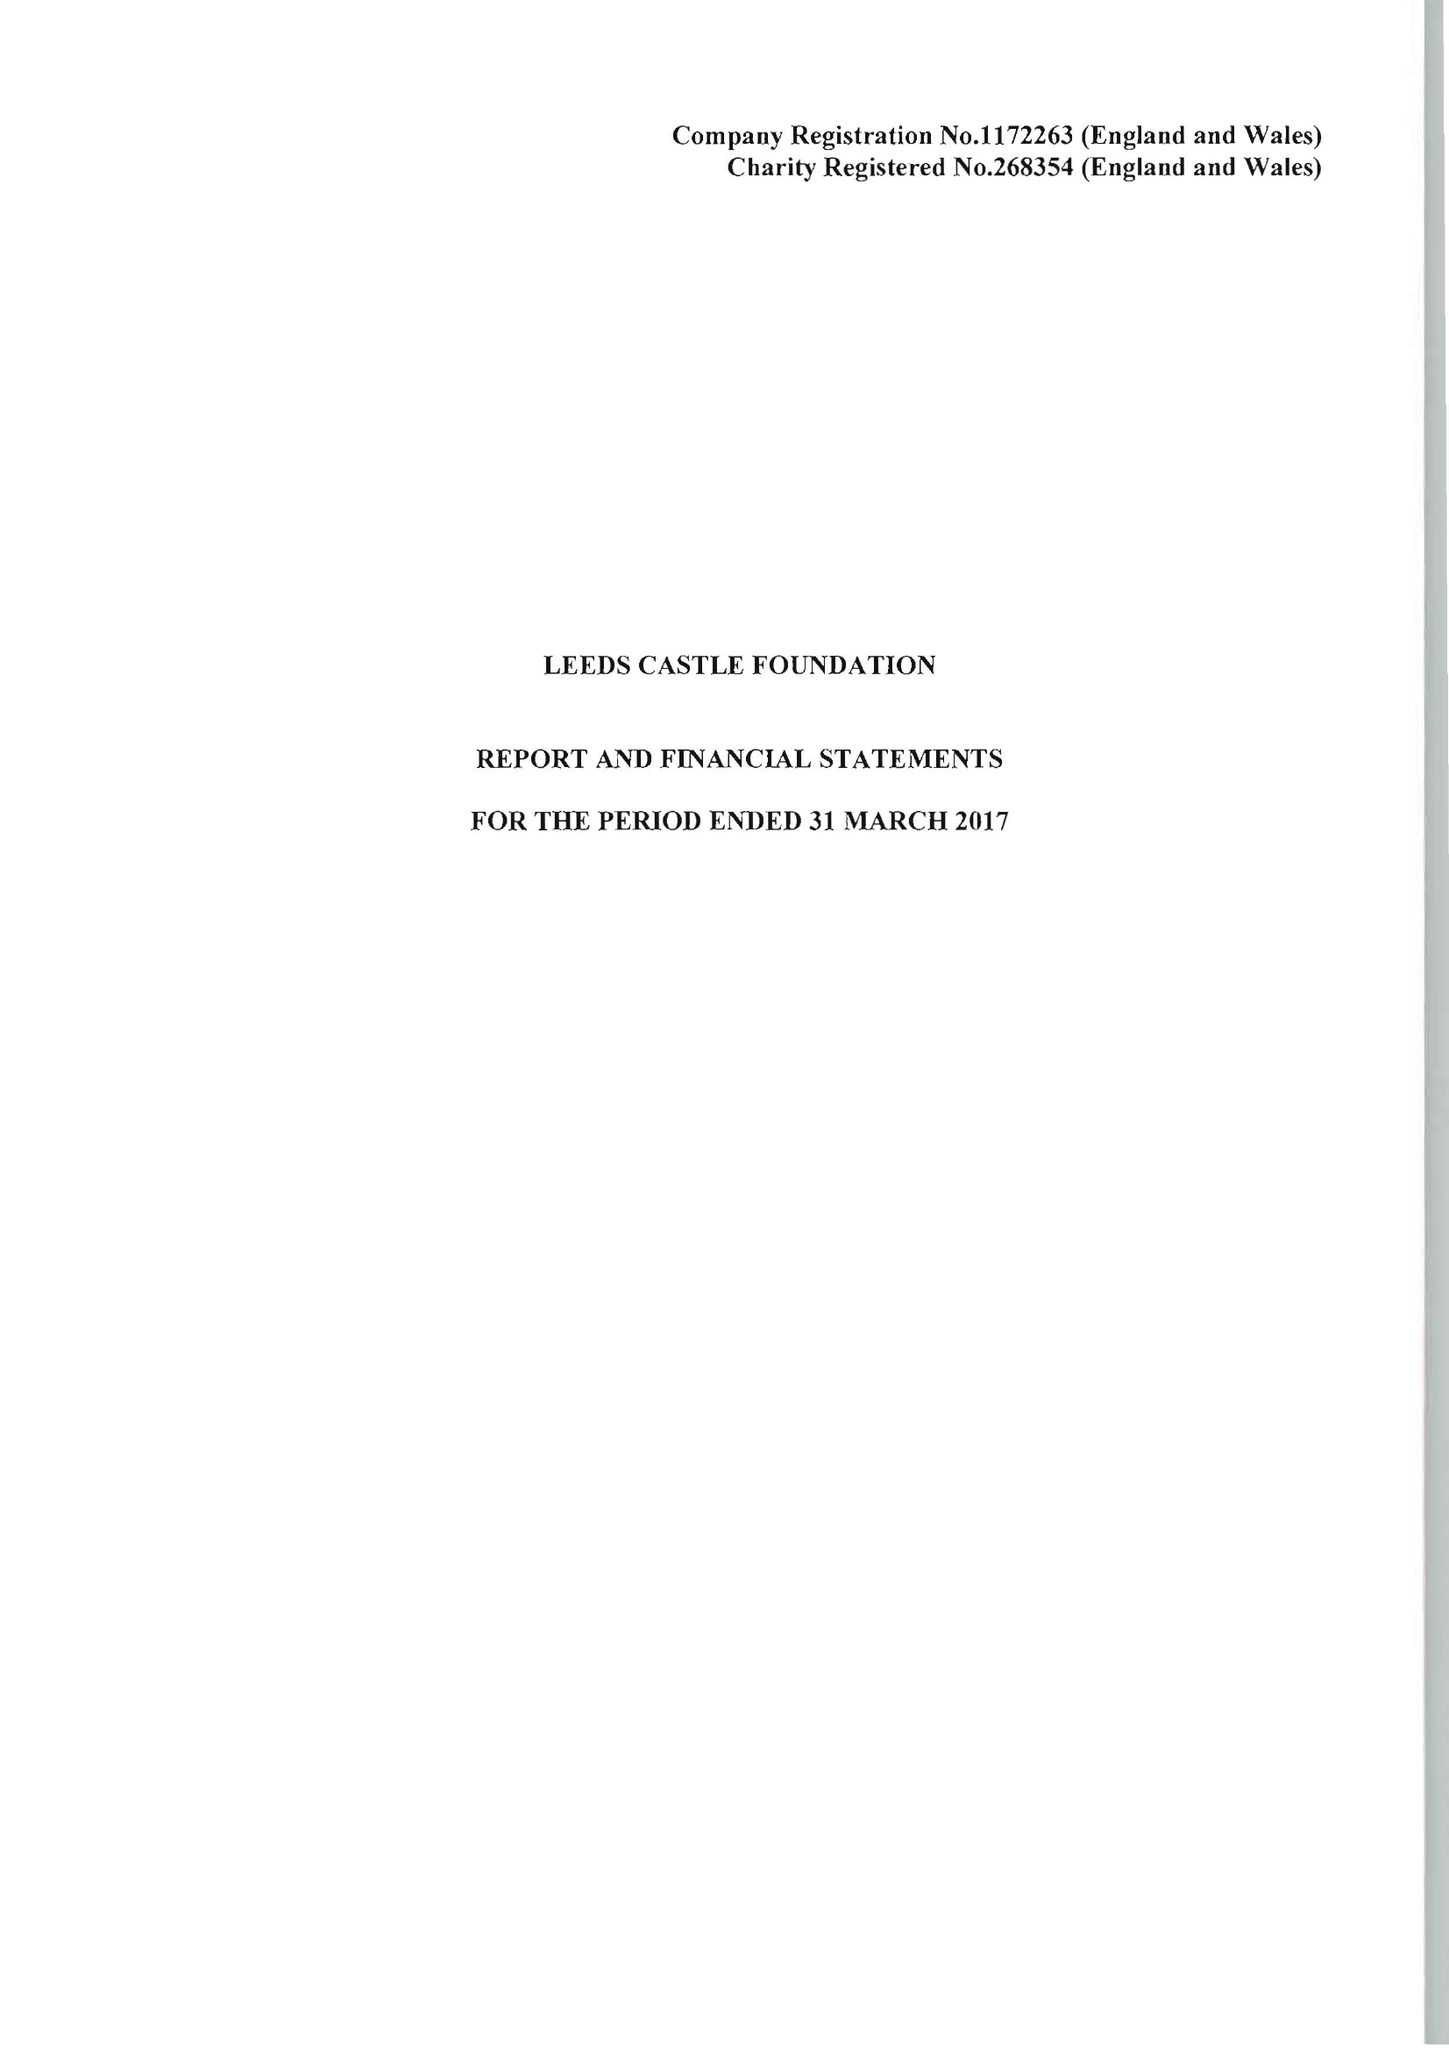What is the value for the income_annually_in_british_pounds?
Answer the question using a single word or phrase. 10851000.00 